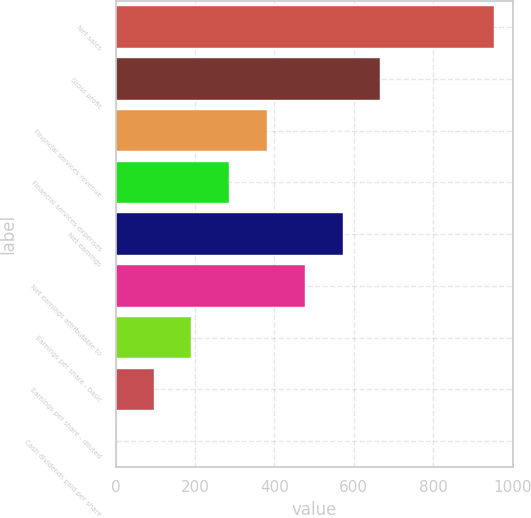Convert chart. <chart><loc_0><loc_0><loc_500><loc_500><bar_chart><fcel>Net sales<fcel>Gross profit<fcel>Financial services revenue<fcel>Financial services expenses<fcel>Net earnings<fcel>Net earnings attributable to<fcel>Earnings per share - basic<fcel>Earnings per share - diluted<fcel>Cash dividends paid per share<nl><fcel>952.5<fcel>667.03<fcel>381.57<fcel>286.41<fcel>571.88<fcel>476.73<fcel>191.26<fcel>96.11<fcel>0.95<nl></chart> 